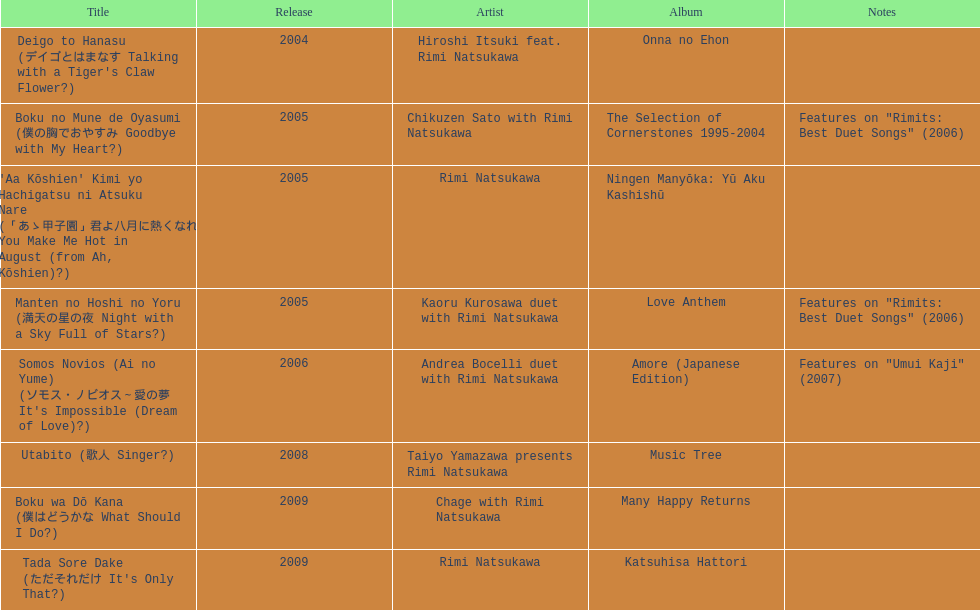How many titles have solely one artist? 2. 